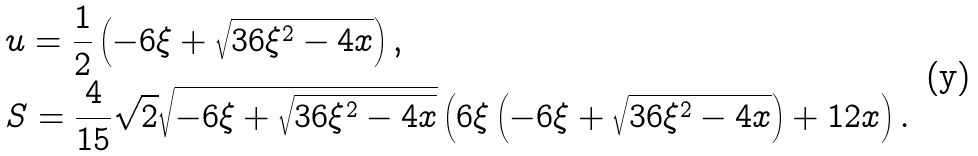<formula> <loc_0><loc_0><loc_500><loc_500>& u = \frac { 1 } { 2 } \left ( - 6 \xi + \sqrt { 3 6 \xi ^ { 2 } - 4 x } \right ) , \\ & S = \frac { 4 } { 1 5 } \sqrt { 2 } \sqrt { - 6 \xi + \sqrt { 3 6 \xi ^ { 2 } - 4 x } } \left ( 6 \xi \left ( - 6 \xi + \sqrt { 3 6 \xi ^ { 2 } - 4 x } \right ) + 1 2 x \right ) .</formula> 